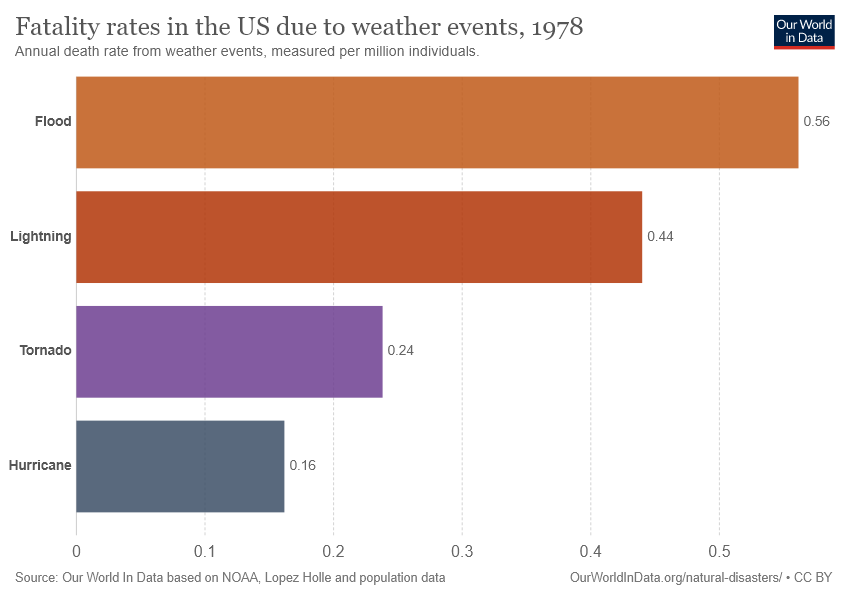List a handful of essential elements in this visual. According to data, the fatality rate associated with floods is 0.4 times that of hurricanes. The color bar representing an event is violet. This event is likely the tornado, based on the context provided. 